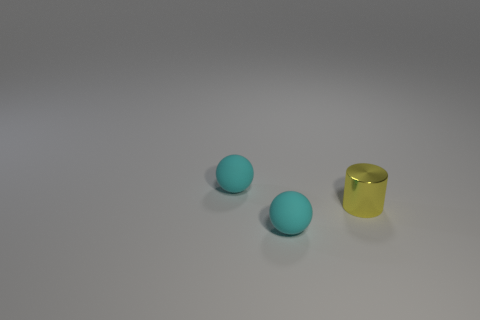There is a tiny metallic thing; is its color the same as the tiny rubber sphere in front of the small yellow thing?
Offer a very short reply. No. There is a yellow metallic cylinder; does it have the same size as the sphere that is behind the tiny yellow thing?
Make the answer very short. Yes. There is a thing behind the tiny cylinder; is its size the same as the cyan rubber object in front of the tiny yellow thing?
Give a very brief answer. Yes. What number of things are small cyan matte objects that are in front of the metallic cylinder or tiny yellow spheres?
Provide a succinct answer. 1. Is there another tiny gray thing of the same shape as the metal object?
Provide a short and direct response. No. Is the number of small rubber objects that are to the right of the tiny cylinder the same as the number of tiny yellow rubber balls?
Keep it short and to the point. Yes. What number of cyan spheres have the same size as the metallic cylinder?
Offer a terse response. 2. There is a tiny yellow shiny cylinder; what number of tiny objects are in front of it?
Make the answer very short. 1. There is a sphere on the left side of the small cyan ball that is in front of the tiny yellow cylinder; what is its material?
Your answer should be very brief. Rubber. Is there another tiny thing of the same color as the tiny metallic object?
Your answer should be very brief. No. 